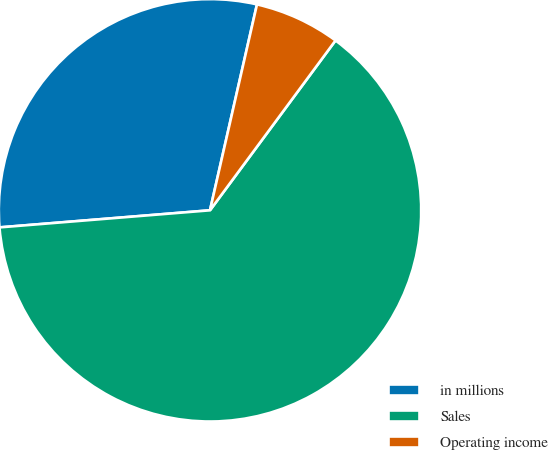Convert chart. <chart><loc_0><loc_0><loc_500><loc_500><pie_chart><fcel>in millions<fcel>Sales<fcel>Operating income<nl><fcel>29.86%<fcel>63.58%<fcel>6.56%<nl></chart> 